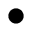Convert formula to latex. <formula><loc_0><loc_0><loc_500><loc_500>\bullet</formula> 